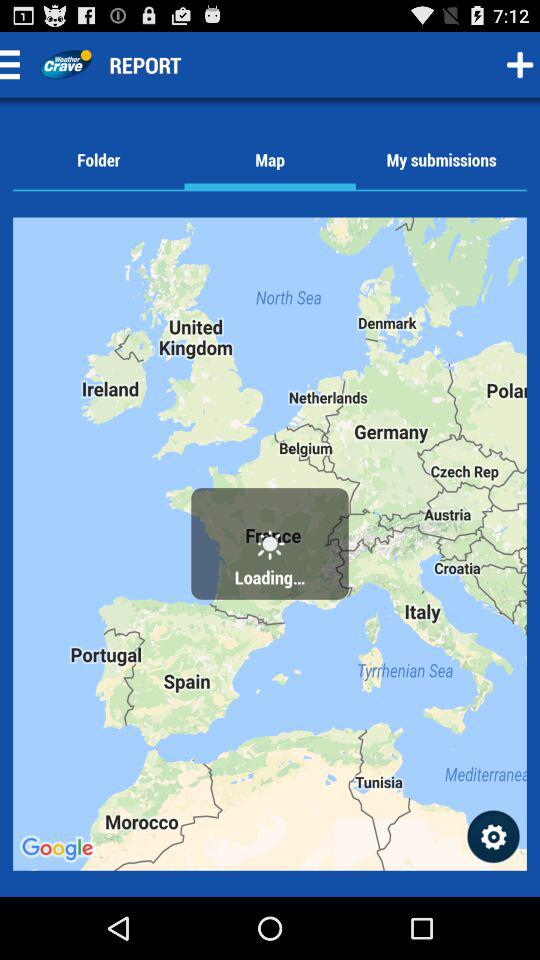What is the name of the application? The application name is "Weather Crave". 